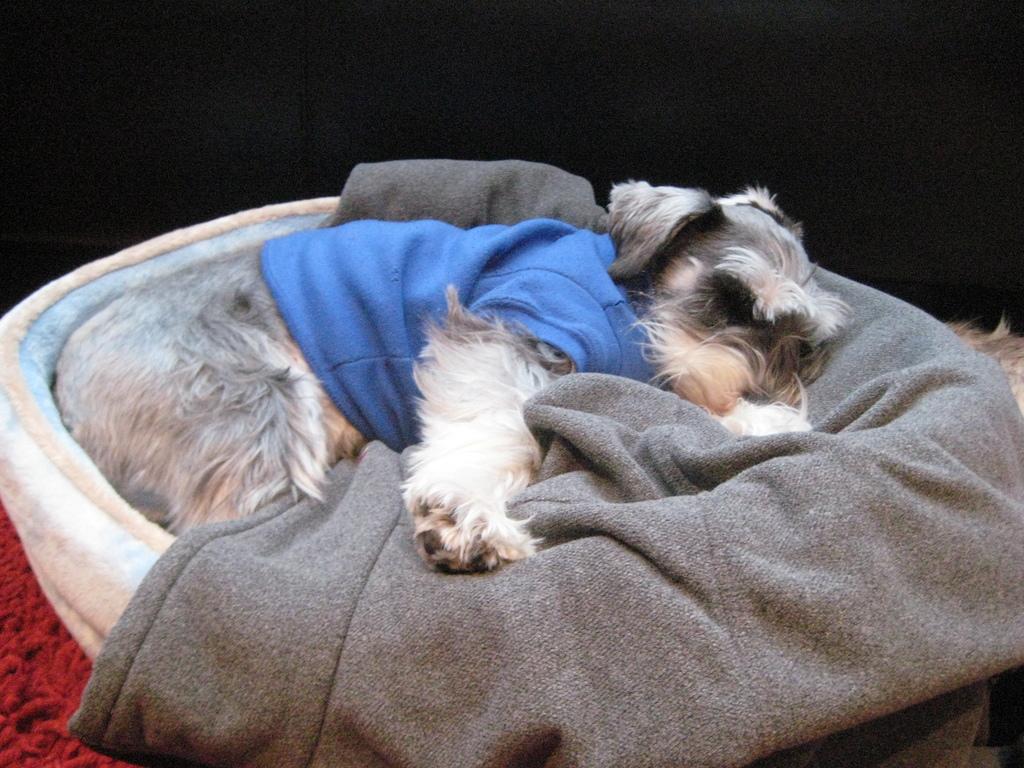Can you describe this image briefly? In this image, we can see a dog is sleeping in the basket. Here there is a cloth. Left side bottom corner, we can see red color object. Background we can see black color. 